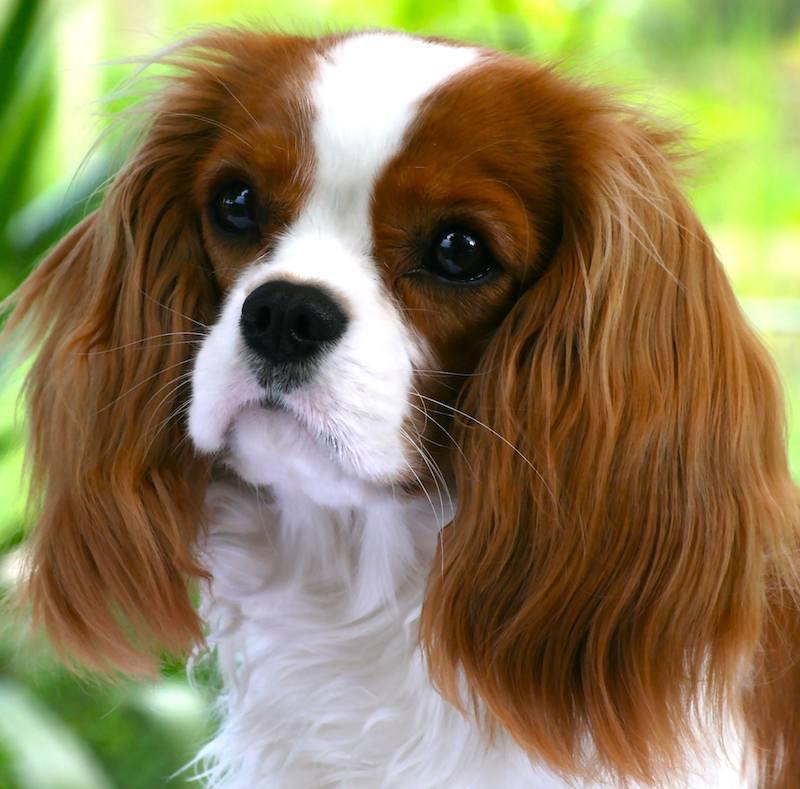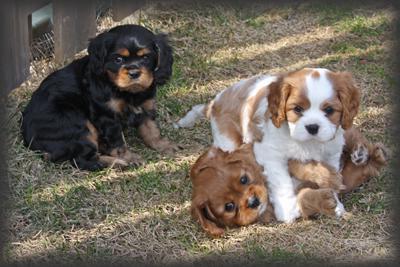The first image is the image on the left, the second image is the image on the right. Assess this claim about the two images: "There are more dogs in the right-hand image than the left.". Correct or not? Answer yes or no. Yes. 